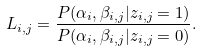<formula> <loc_0><loc_0><loc_500><loc_500>L _ { i , j } = \frac { P ( \alpha _ { i } , \beta _ { i , j } | z _ { i , j } = 1 ) } { P ( \alpha _ { i } , \beta _ { i , j } | z _ { i , j } = 0 ) } .</formula> 